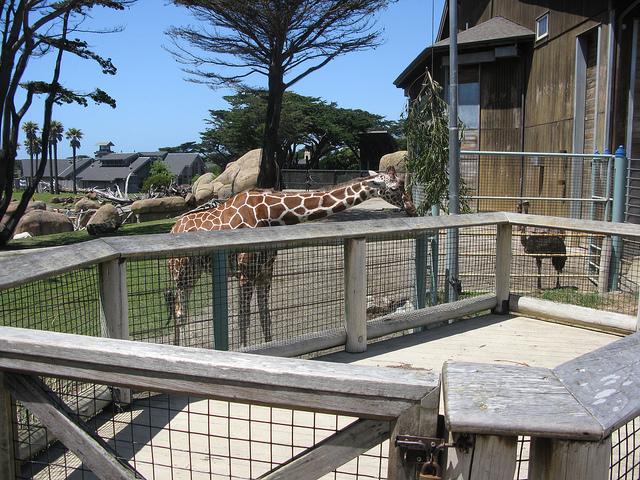Are there different animals in this picture?
Give a very brief answer. Yes. Is this a zoo?
Answer briefly. Yes. How many children are near the giraffe?
Be succinct. 0. Is this animal taller than the average man?
Quick response, please. Yes. What color is the roof?
Give a very brief answer. Brown. 